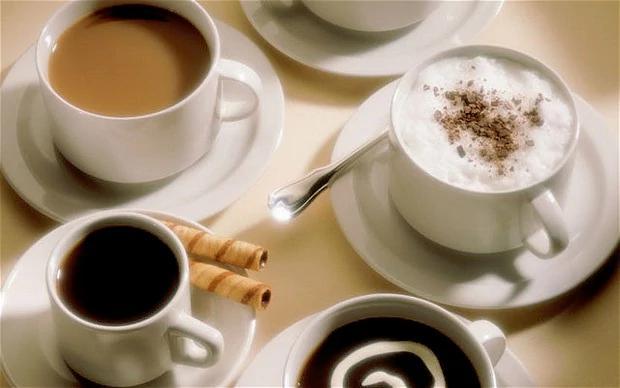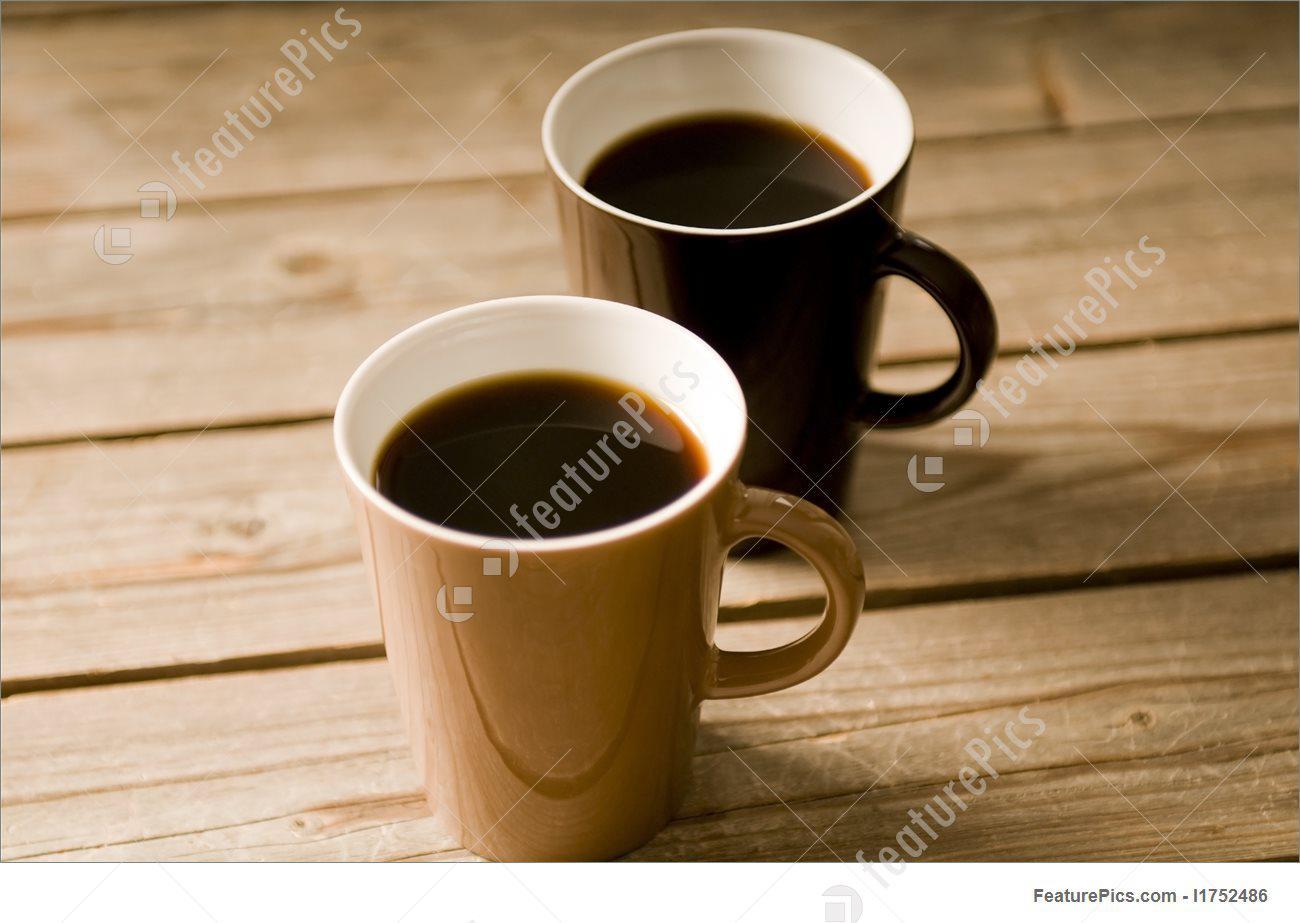The first image is the image on the left, the second image is the image on the right. Assess this claim about the two images: "All of the mugs are sitting on saucers.". Correct or not? Answer yes or no. No. The first image is the image on the left, the second image is the image on the right. Analyze the images presented: Is the assertion "Several coffee beans are near a white cup of steaming beverage on a white saucer." valid? Answer yes or no. No. 